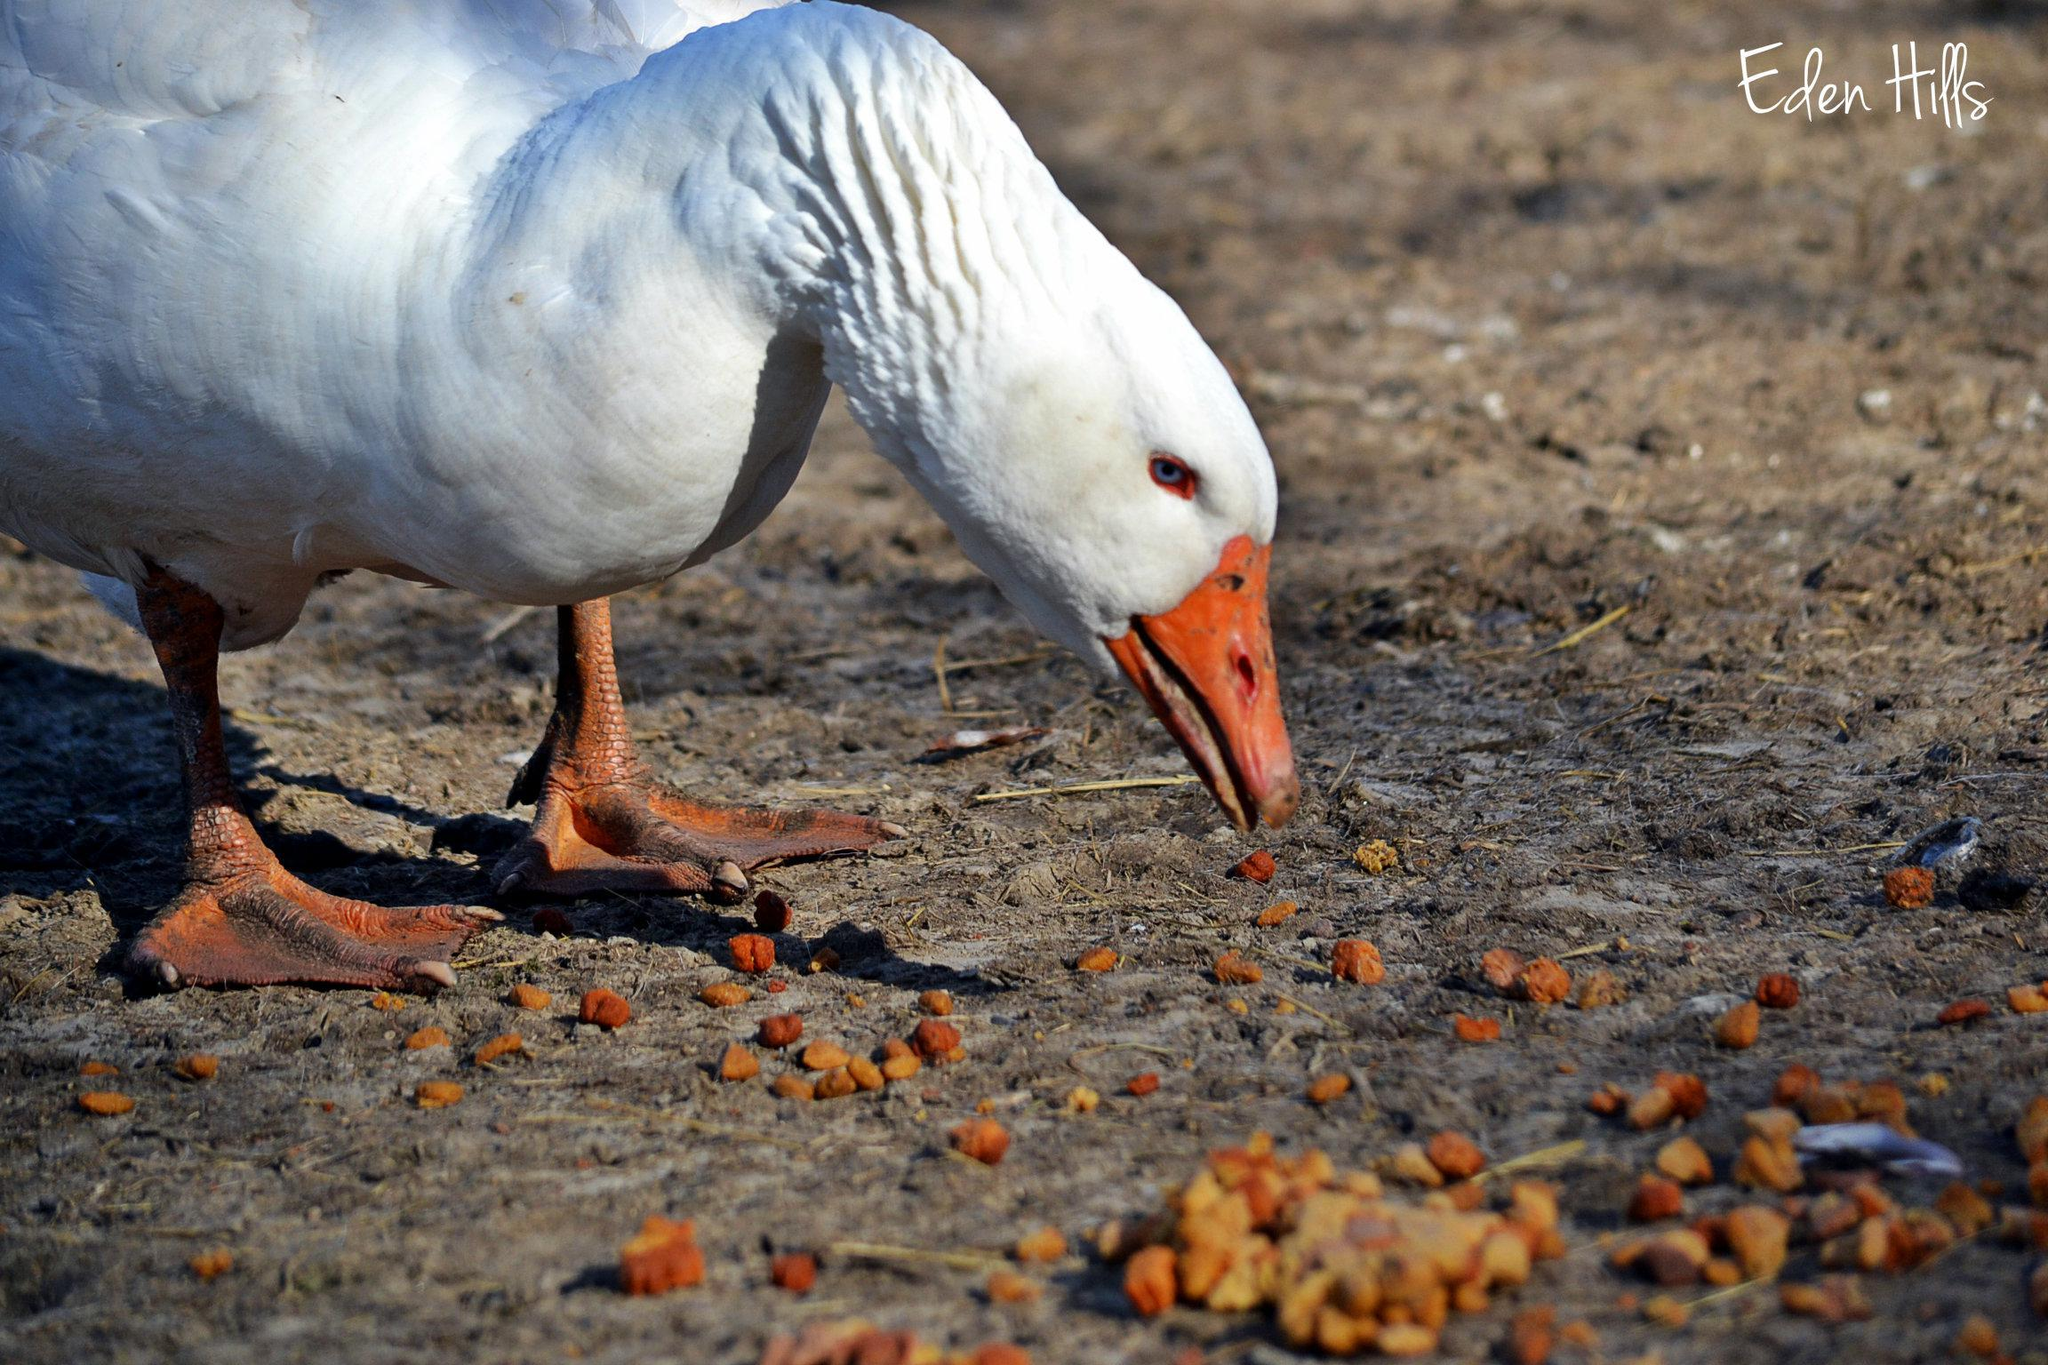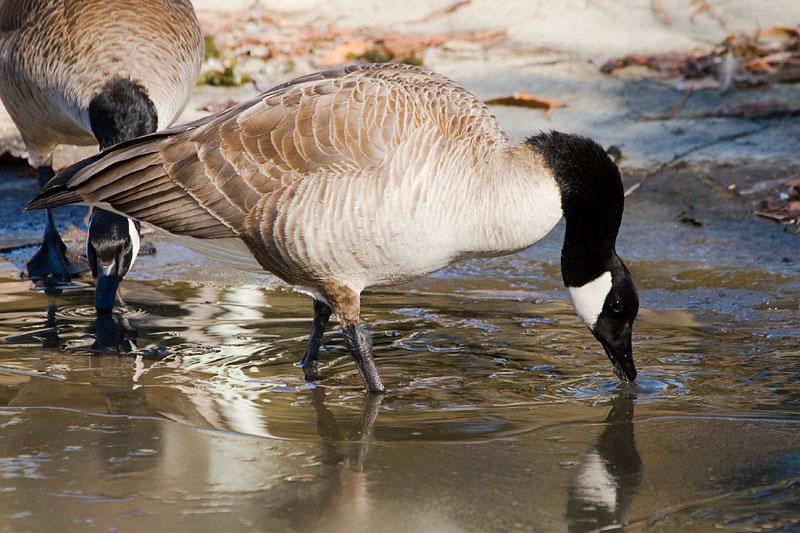The first image is the image on the left, the second image is the image on the right. For the images shown, is this caption "An image contains no more than one white duck." true? Answer yes or no. Yes. The first image is the image on the left, the second image is the image on the right. Analyze the images presented: Is the assertion "One image shows black-necked Canadian geese standing in shallow water, and the other image includes a white duck eating something." valid? Answer yes or no. Yes. 